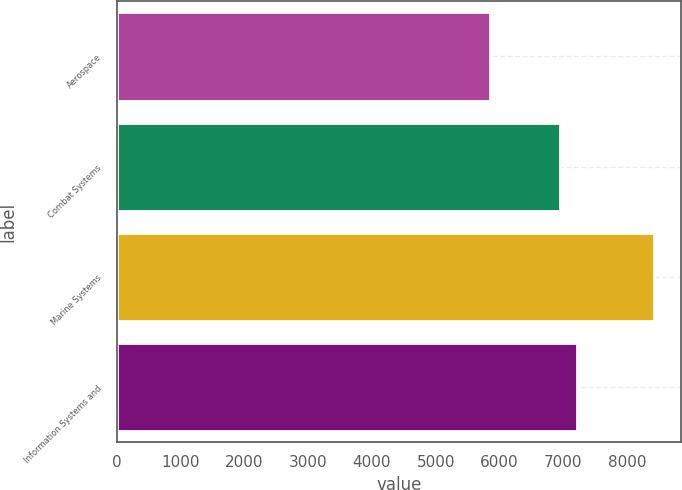Convert chart to OTSL. <chart><loc_0><loc_0><loc_500><loc_500><bar_chart><fcel>Aerospace<fcel>Combat Systems<fcel>Marine Systems<fcel>Information Systems and<nl><fcel>5853<fcel>6954<fcel>8419<fcel>7210.6<nl></chart> 